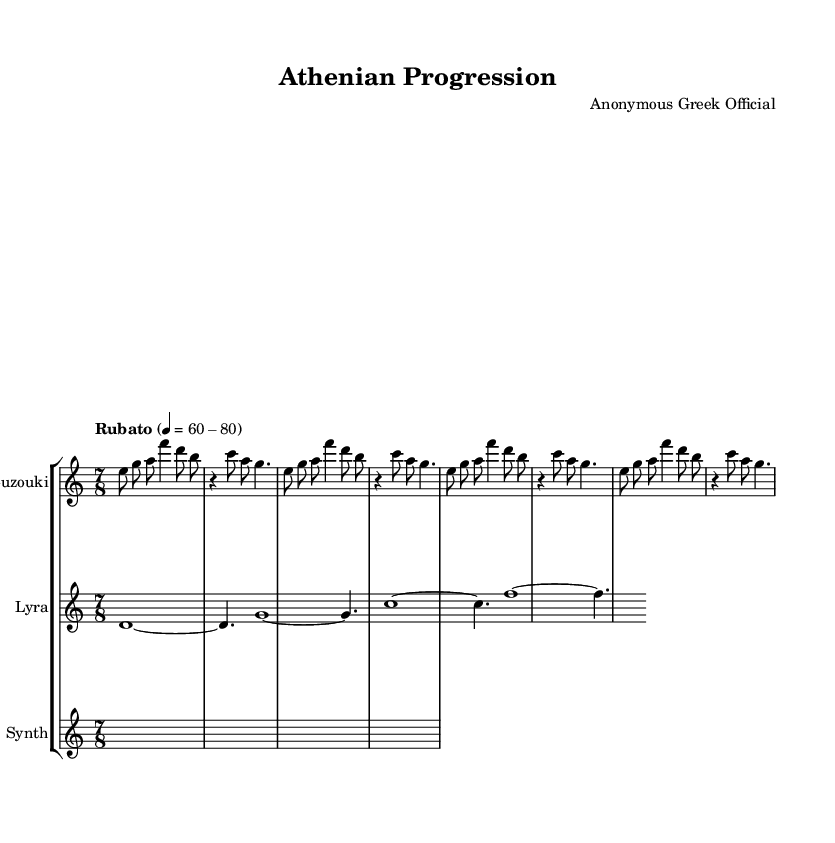What is the time signature of this music? The time signature is found at the beginning of the piece and is indicated as 7/8, representing seven eighth-note beats per measure.
Answer: 7/8 What is the tempo marking of this piece? The tempo marking "Rubato" is specified in the score, indicating a flexible tempo, and it suggests a range of beats per minute from 60 to 80.
Answer: Rubato, 60-80 How many measures are in the bouzouki part? By counting the groups of notes separated by bar lines in the bouzouki music section, we find that there are eight measures in total.
Answer: 8 What instruments are utilized in this composition? The instruments listed in the score for this piece are Bouzouki, Lyra, and Synth. This is indicated in the staff group titles at the beginning of each instrument's music.
Answer: Bouzouki, Lyra, Synth How does the synth music section differ from the other parts? The synth section is unique because it contains rests and longer note durations (sustained) indicated as s2..*4, contrasting with the bouzouki and lyra's more melodic and rhythmic characteristics.
Answer: Sustained notes What is the rhythmic feel of the piece based on the time signature? The time signature of 7/8 suggests an uneven rhythmic feel, typically emphasizing the off beats, which can create a more complex and avant-garde expression compared to more common signatures like 4/4.
Answer: Uneven rhythmic feel Which instrument has the longest held notes in this piece? By examining the scores, the Lyra section features longer held notes (whole notes) compared to the other instruments, specifically indicated with d1~ and g1~ at the start of its measures.
Answer: Lyra 